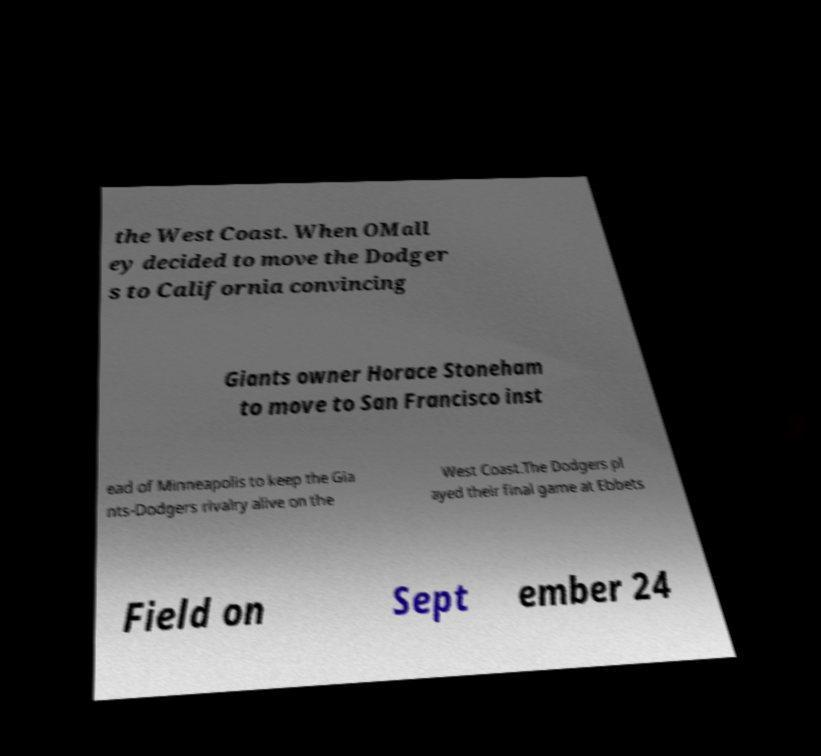Could you assist in decoding the text presented in this image and type it out clearly? the West Coast. When OMall ey decided to move the Dodger s to California convincing Giants owner Horace Stoneham to move to San Francisco inst ead of Minneapolis to keep the Gia nts-Dodgers rivalry alive on the West Coast.The Dodgers pl ayed their final game at Ebbets Field on Sept ember 24 